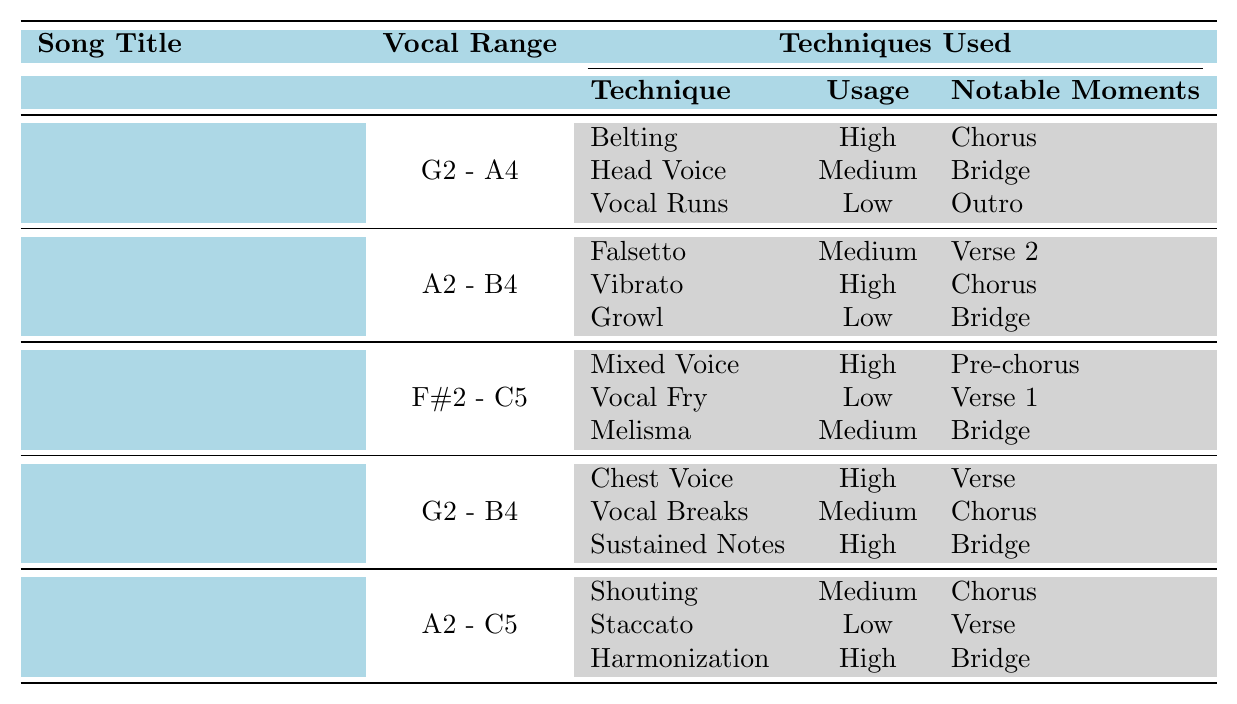What is the vocal range of the song "Gratitude"? The table shows that the vocal range for "Gratitude" is G2 - A4.
Answer: G2 - A4 Which song uses the "Vibrato" technique in its chorus? According to the table, "Too Good To Not Believe" uses the "Vibrato" technique in its chorus.
Answer: Too Good To Not Believe How many songs utilize the "High" usage for their techniques? The table lists three songs with techniques used as "High": "Gratitude," "Graves Into Gardens," "This Is A Move," and "Rattle!" Totaling to four songs.
Answer: Four What technique is noted for its usage as "Low" in the song "Graves Into Gardens"? The table indicates that "Vocal Fry" is the technique used as "Low" in "Graves Into Gardens."
Answer: Vocal Fry Is there a song that features both "Belting" and "Vocal Breaks"? The table does not show any song featuring both "Belting" and "Vocal Breaks," as "Belting" is only used in "Gratitude" and "Vocal Breaks" in "This Is A Move."
Answer: No Which song employs the "Head Voice" technique, and in which section? The table indicates that "Gratitude" utilizes the "Head Voice" technique in the "Bridge" section.
Answer: Gratitude, Bridge What is the collective vocal range of the songs "This Is A Move" and "Rattle!"? The vocal ranges are G2 - B4 for "This Is A Move" and A2 - C5 for "Rattle!". To find the collective ranges, we can see they overlap, covering G2 - C5.
Answer: G2 - C5 Identify the techniques used in the first two songs listed in the table. The first two songs and their techniques are: "Gratitude" uses Belting (High), Head Voice (Medium), and Vocal Runs (Low); "Too Good To Not Believe" uses Falsetto (Medium), Vibrato (High), and Growl (Low).
Answer: See explanation How many notable moments does "Rattle!" have listed in the table? "Rattle!" has three notable moments listed: Chorus, Verse, and Bridge.
Answer: Three Which song has the widest vocal range, and what is that range? "Graves Into Gardens" has the widest vocal range of F#2 - C5 according to the table.
Answer: F#2 - C5 